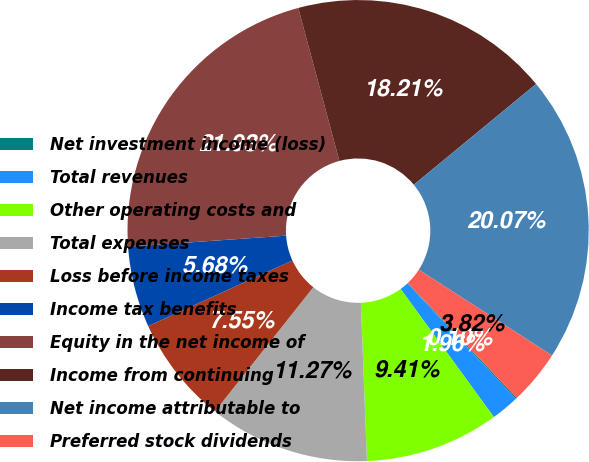<chart> <loc_0><loc_0><loc_500><loc_500><pie_chart><fcel>Net investment income (loss)<fcel>Total revenues<fcel>Other operating costs and<fcel>Total expenses<fcel>Loss before income taxes<fcel>Income tax benefits<fcel>Equity in the net income of<fcel>Income from continuing<fcel>Net income attributable to<fcel>Preferred stock dividends<nl><fcel>0.1%<fcel>1.96%<fcel>9.41%<fcel>11.27%<fcel>7.55%<fcel>5.68%<fcel>21.93%<fcel>18.21%<fcel>20.07%<fcel>3.82%<nl></chart> 